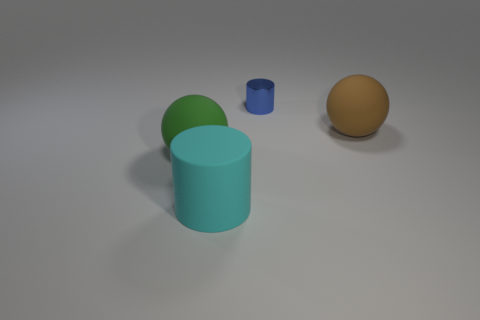Add 2 cyan metallic spheres. How many objects exist? 6 Subtract 1 spheres. How many spheres are left? 1 Subtract all purple cylinders. Subtract all gray spheres. How many cylinders are left? 2 Subtract all brown cylinders. How many green balls are left? 1 Subtract all small red matte spheres. Subtract all large brown rubber objects. How many objects are left? 3 Add 3 big cyan matte objects. How many big cyan matte objects are left? 4 Add 2 green rubber spheres. How many green rubber spheres exist? 3 Subtract 0 brown cylinders. How many objects are left? 4 